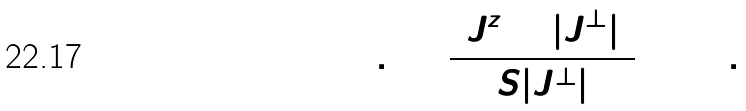<formula> <loc_0><loc_0><loc_500><loc_500>1 + 0 . 2 5 8 \frac { ( J _ { 2 } ^ { z } + | J _ { 2 } ^ { \perp } | ) } { S | J _ { 2 } ^ { \perp } | } = 0 \ \, .</formula> 